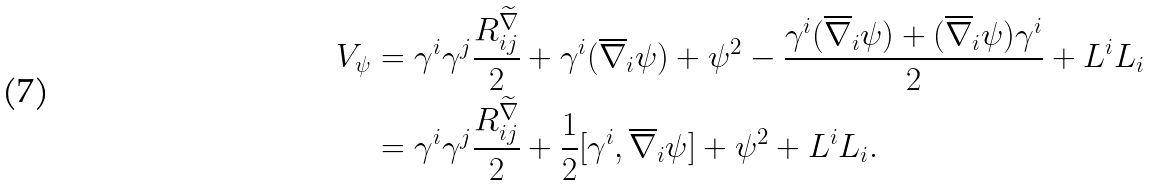<formula> <loc_0><loc_0><loc_500><loc_500>V _ { \psi } & = \gamma ^ { i } \gamma ^ { j } \frac { R _ { i j } ^ { \widetilde { \nabla } } } { 2 } + \gamma ^ { i } ( \overline { \nabla } _ { i } \psi ) + \psi ^ { 2 } - \frac { \gamma ^ { i } ( \overline { \nabla } _ { i } \psi ) + ( \overline { \nabla } _ { i } \psi ) \gamma ^ { i } } { 2 } + L ^ { i } L _ { i } \\ & = \gamma ^ { i } \gamma ^ { j } \frac { R _ { i j } ^ { \widetilde { \nabla } } } { 2 } + \frac { 1 } { 2 } [ \gamma ^ { i } , \overline { \nabla } _ { i } \psi ] + \psi ^ { 2 } + L ^ { i } L _ { i } .</formula> 